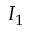<formula> <loc_0><loc_0><loc_500><loc_500>I _ { 1 }</formula> 